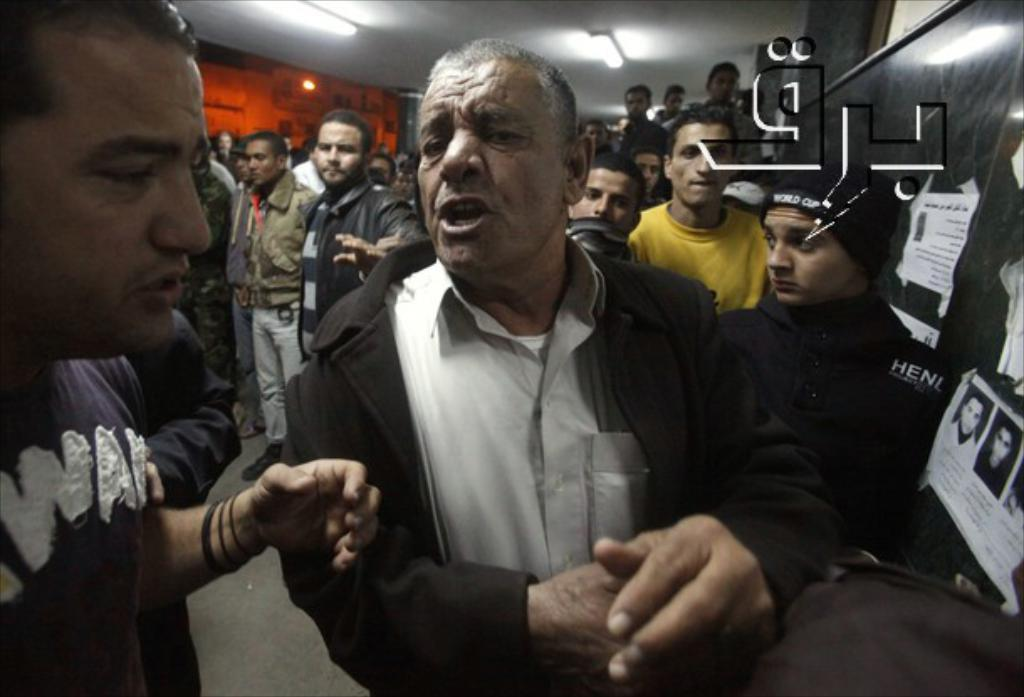What can be seen in the image in terms of human presence? There are people standing in the image. What part of the room can be seen in the image? The floor, ceiling, and at least one wall are visible in the image. Are there any lighting features in the image? Yes, lights are present in the image. What is on the wall in the image? There is a board with text papers in the image. Is there any branding or identification in the image? Yes, there is a logo visible in the image. Can you see any birds flying in the image? No, there are no birds visible in the image. Is there a rabbit hopping along the border of the room in the image? No, there is no rabbit or border present in the image. 